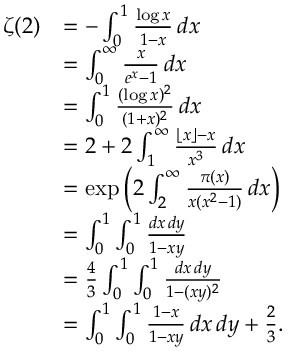<formula> <loc_0><loc_0><loc_500><loc_500>{ \begin{array} { r l } { \zeta ( 2 ) } & { = - \int _ { 0 } ^ { 1 } { \frac { \log x } { 1 - x } } \, d x } \\ & { = \int _ { 0 } ^ { \infty } { \frac { x } { e ^ { x } - 1 } } \, d x } \\ & { = \int _ { 0 } ^ { 1 } { \frac { ( \log x ) ^ { 2 } } { ( 1 + x ) ^ { 2 } } } \, d x } \\ & { = 2 + 2 \int _ { 1 } ^ { \infty } { \frac { \lfloor x \rfloor - x } { x ^ { 3 } } } \, d x } \\ & { = \exp \left ( 2 \int _ { 2 } ^ { \infty } { \frac { \pi ( x ) } { x ( x ^ { 2 } - 1 ) } } \, d x \right ) } \\ & { = \int _ { 0 } ^ { 1 } \int _ { 0 } ^ { 1 } { \frac { d x \, d y } { 1 - x y } } } \\ & { = { \frac { 4 } { 3 } } \int _ { 0 } ^ { 1 } \int _ { 0 } ^ { 1 } { \frac { d x \, d y } { 1 - ( x y ) ^ { 2 } } } } \\ & { = \int _ { 0 } ^ { 1 } \int _ { 0 } ^ { 1 } { \frac { 1 - x } { 1 - x y } } \, d x \, d y + { \frac { 2 } { 3 } } . } \end{array} }</formula> 